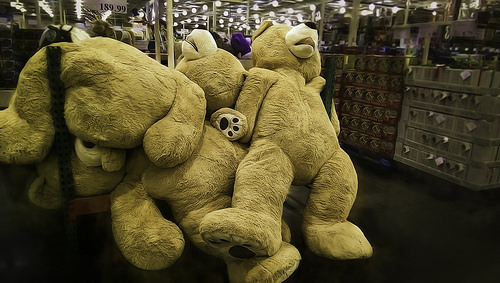<image>
Is the cart next to the cart? Yes. The cart is positioned adjacent to the cart, located nearby in the same general area. Is the canister on the bear? No. The canister is not positioned on the bear. They may be near each other, but the canister is not supported by or resting on top of the bear. 